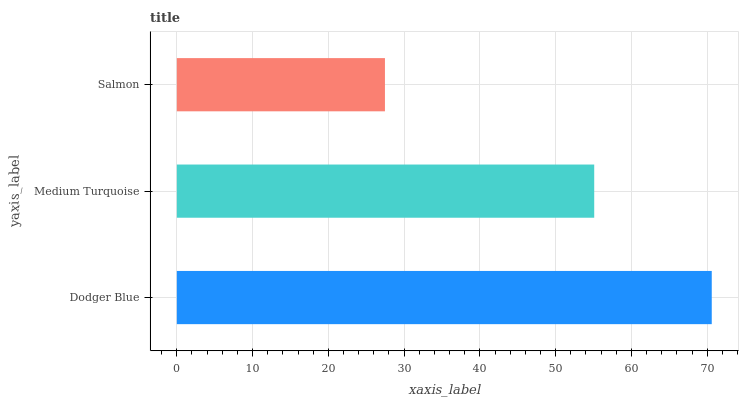Is Salmon the minimum?
Answer yes or no. Yes. Is Dodger Blue the maximum?
Answer yes or no. Yes. Is Medium Turquoise the minimum?
Answer yes or no. No. Is Medium Turquoise the maximum?
Answer yes or no. No. Is Dodger Blue greater than Medium Turquoise?
Answer yes or no. Yes. Is Medium Turquoise less than Dodger Blue?
Answer yes or no. Yes. Is Medium Turquoise greater than Dodger Blue?
Answer yes or no. No. Is Dodger Blue less than Medium Turquoise?
Answer yes or no. No. Is Medium Turquoise the high median?
Answer yes or no. Yes. Is Medium Turquoise the low median?
Answer yes or no. Yes. Is Dodger Blue the high median?
Answer yes or no. No. Is Dodger Blue the low median?
Answer yes or no. No. 